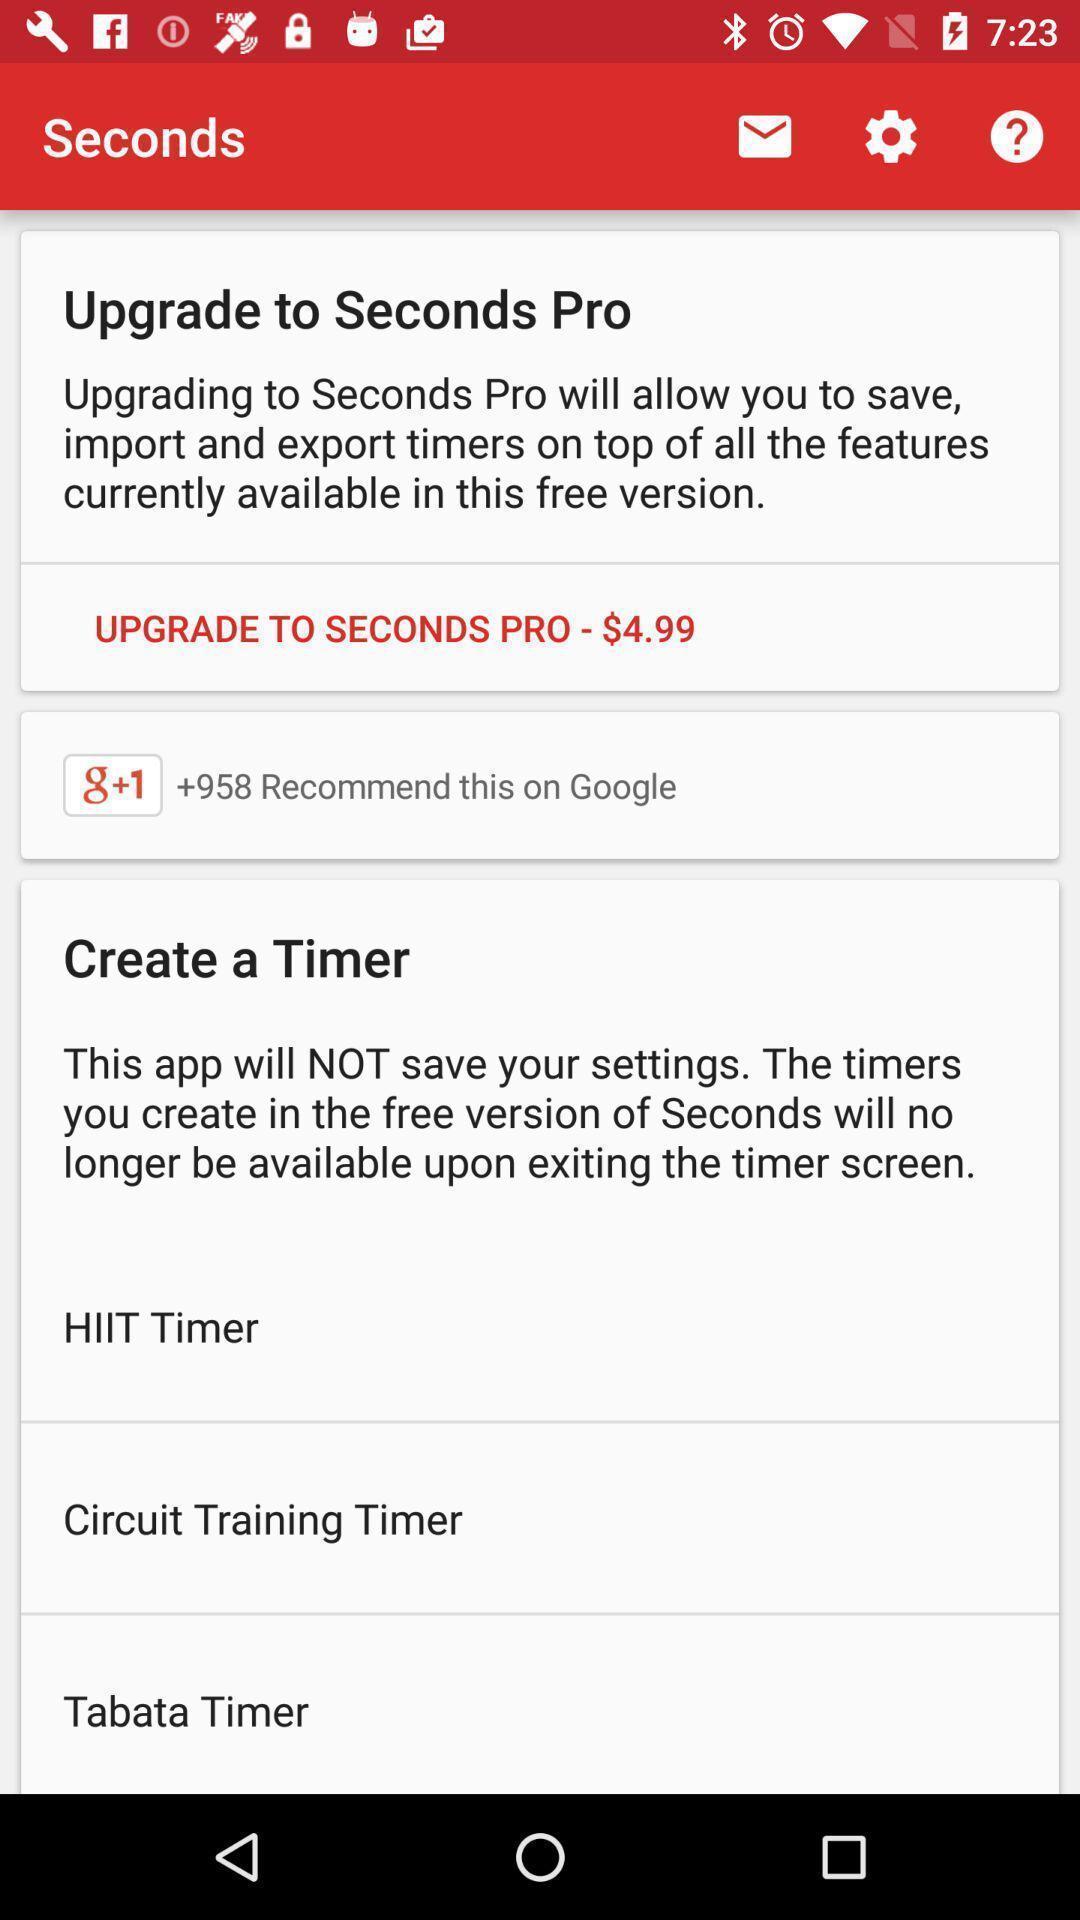Describe the visual elements of this screenshot. Window displaying a mobile banking app. 